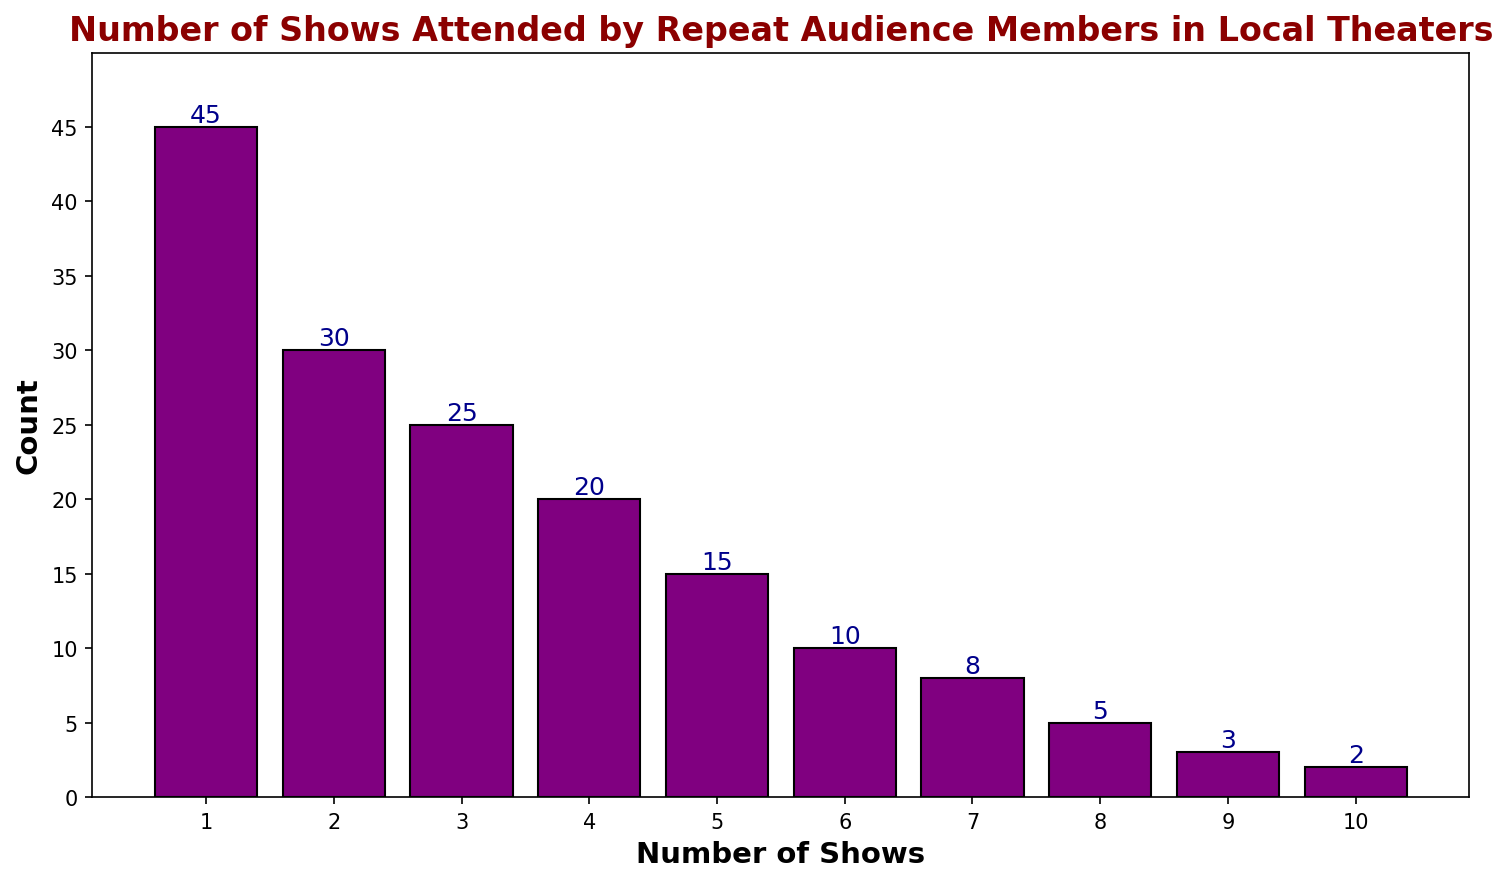How many people attended exactly 4 shows? Count the height of the bar associated with '4 Shows' value. Check the y-axis to read this height.
Answer: 20 What is the total count of people who attended fewer than 3 shows? Look up the counts for '1 Show' and '2 Shows'. Sum these counts: 45 + 30
Answer: 75 Which number of shows was attended by the highest number of people, and what is that number? Identify the tallest bar and check its x-axis and y-axis coordinates. The tallest bar corresponds to '1 Show' and its height is 45.
Answer: 1 Show, 45 How many more people attended 1 show than 6 shows? Look up the counts for '1 Show' and '6 Shows'. Subtract these counts to find the difference: 45 - 10.
Answer: 35 What is the average count of people attending 5 or more shows? Look up the counts for '5', '6', '7', '8', '9', and '10 Shows'. Sum these counts and divide by 6. Calculation: (15 + 10 + 8 + 5 + 3 + 2) / 6 = 43 / 6
Answer: 7.17 Which number of shows has the lowest number of attendees, and what is that number? Identify the shortest bar on the chart and check its x-axis and y-axis coordinates. The shortest bar corresponds to '10 Shows' with a height of 2.
Answer: 10 Shows, 2 Are there more people who attended 3 shows or 7 shows? Compare the counts for '3 Shows' (25) and '7 Shows' (8). Since 25 > 8, more people attended 3 shows.
Answer: 3 Shows What proportion of the total audience attended exactly 2 and 3 shows combined? Sum the counts for '2 Shows' and '3 Shows', then divide by the total audience count. Calculation: (30 + 25) / (45 + 30 + 25 + 20 + 15 + 10 + 8 + 5 + 3 + 2) = 55 / 163
Answer: 0.337 or 33.7% How does the number of attendees for '5 Shows' compare to '8 Shows'? Compare the counts for '5 Shows' (15) and '8 Shows' (5). Since 15 is three times larger than 5.
Answer: 3 times larger What is the mean number of shows attended by the audience with counts between 4 and 6 inclusive? Look up the counts for '4', '5', and '6 Shows'. Sum the counts and divide by the number of shows. Calculation: (20 + 15 + 10) / 3 = 45 / 3
Answer: 15 